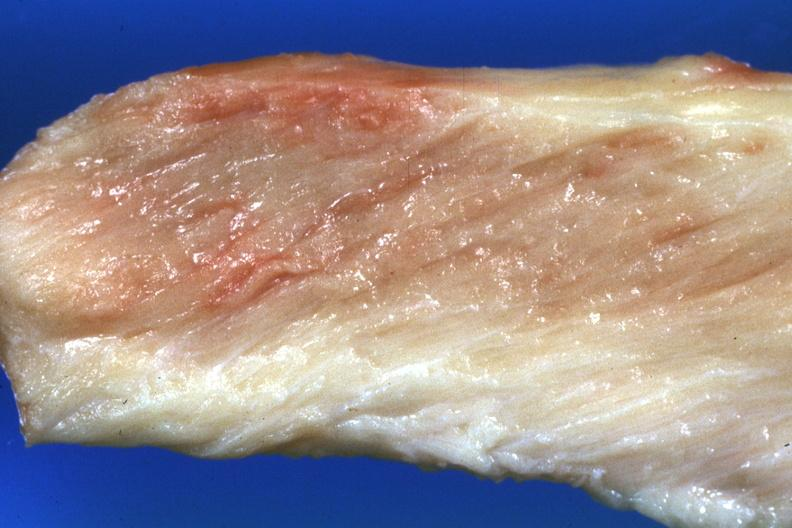do morphology pale muscle?
Answer the question using a single word or phrase. No 